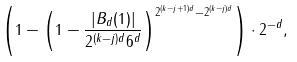<formula> <loc_0><loc_0><loc_500><loc_500>\left ( 1 - \left ( 1 - \frac { | B _ { d } ( 1 ) | } { 2 ^ { ( k - j ) d } 6 ^ { d } } \right ) ^ { 2 ^ { ( k - j + 1 ) d } - 2 ^ { ( k - j ) d } } \right ) \cdot 2 ^ { - d } ,</formula> 